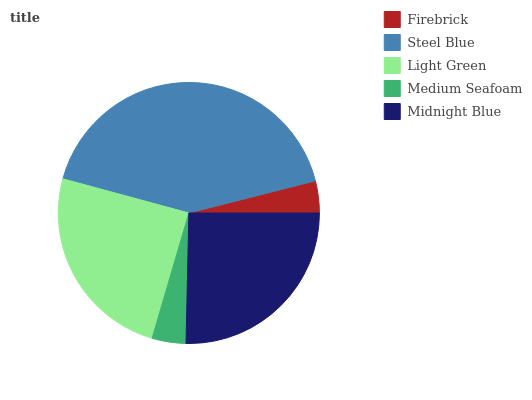Is Firebrick the minimum?
Answer yes or no. Yes. Is Steel Blue the maximum?
Answer yes or no. Yes. Is Light Green the minimum?
Answer yes or no. No. Is Light Green the maximum?
Answer yes or no. No. Is Steel Blue greater than Light Green?
Answer yes or no. Yes. Is Light Green less than Steel Blue?
Answer yes or no. Yes. Is Light Green greater than Steel Blue?
Answer yes or no. No. Is Steel Blue less than Light Green?
Answer yes or no. No. Is Light Green the high median?
Answer yes or no. Yes. Is Light Green the low median?
Answer yes or no. Yes. Is Midnight Blue the high median?
Answer yes or no. No. Is Firebrick the low median?
Answer yes or no. No. 